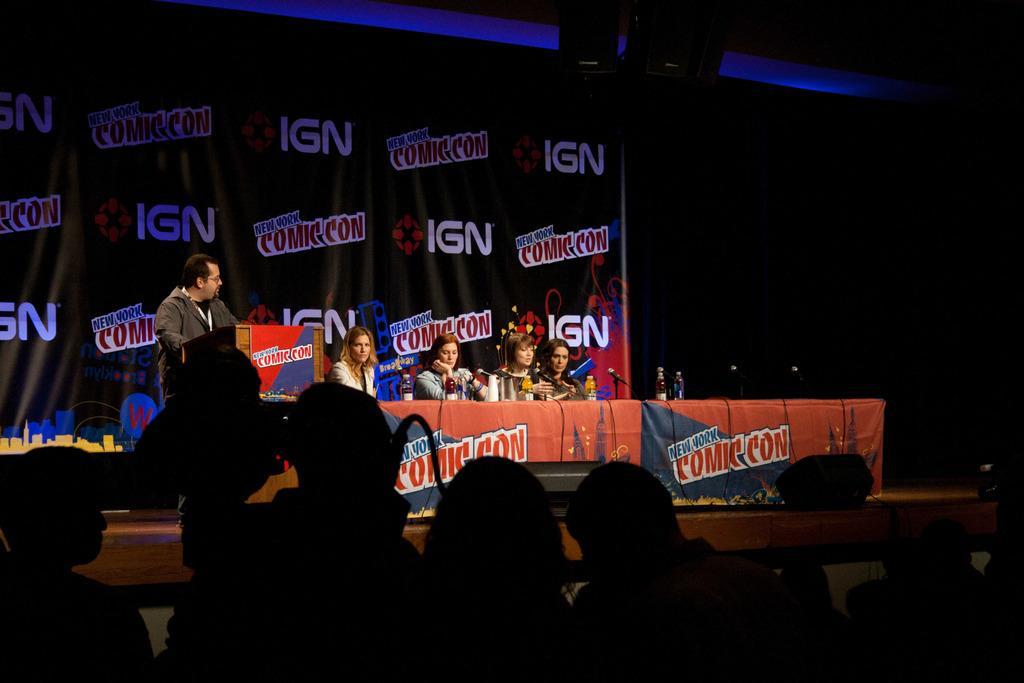Could you give a brief overview of what you see in this image? This image seems to be clicked in a hall, in the front there are few people sitting and standing on stage with mics in front of them along with water bottles, behind them there is banner, in the front there are few people standing and sitting. 